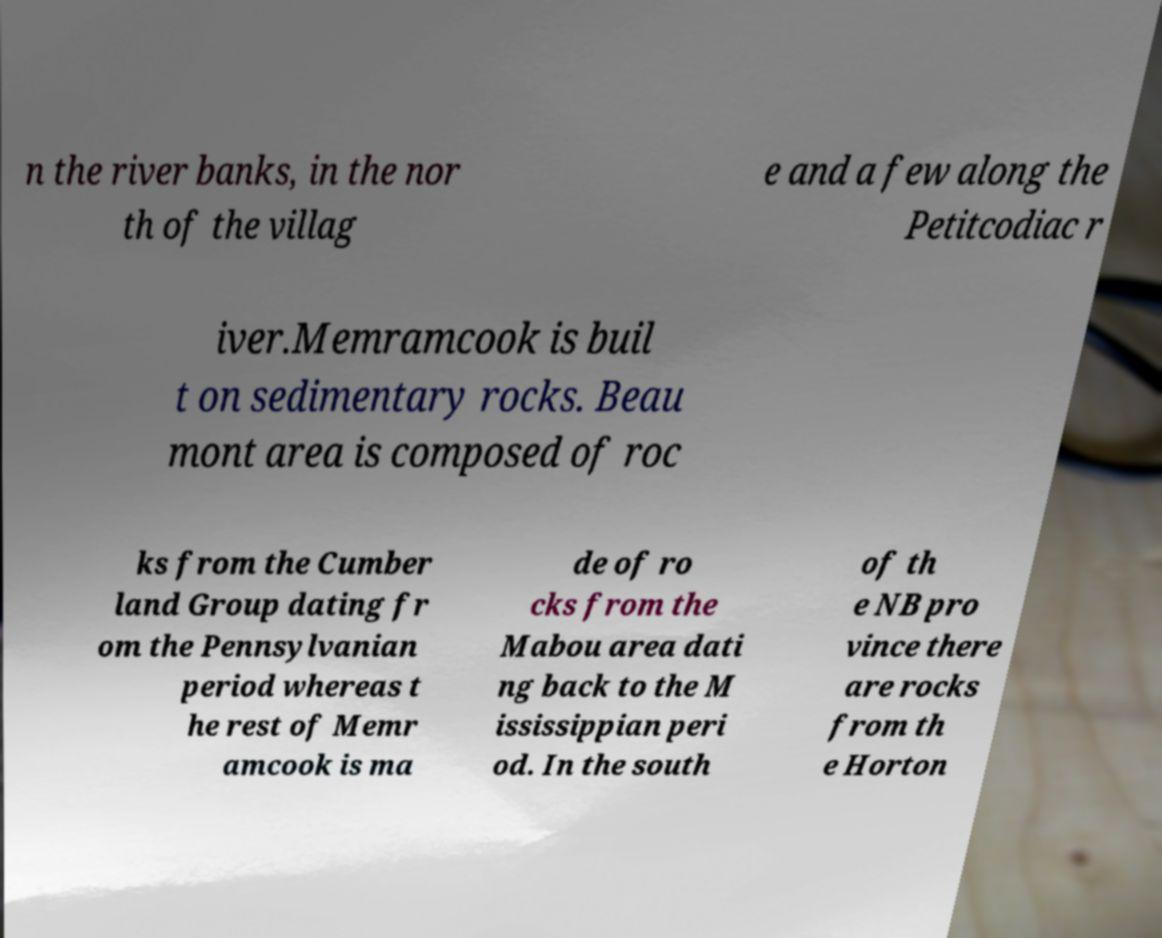I need the written content from this picture converted into text. Can you do that? n the river banks, in the nor th of the villag e and a few along the Petitcodiac r iver.Memramcook is buil t on sedimentary rocks. Beau mont area is composed of roc ks from the Cumber land Group dating fr om the Pennsylvanian period whereas t he rest of Memr amcook is ma de of ro cks from the Mabou area dati ng back to the M ississippian peri od. In the south of th e NB pro vince there are rocks from th e Horton 